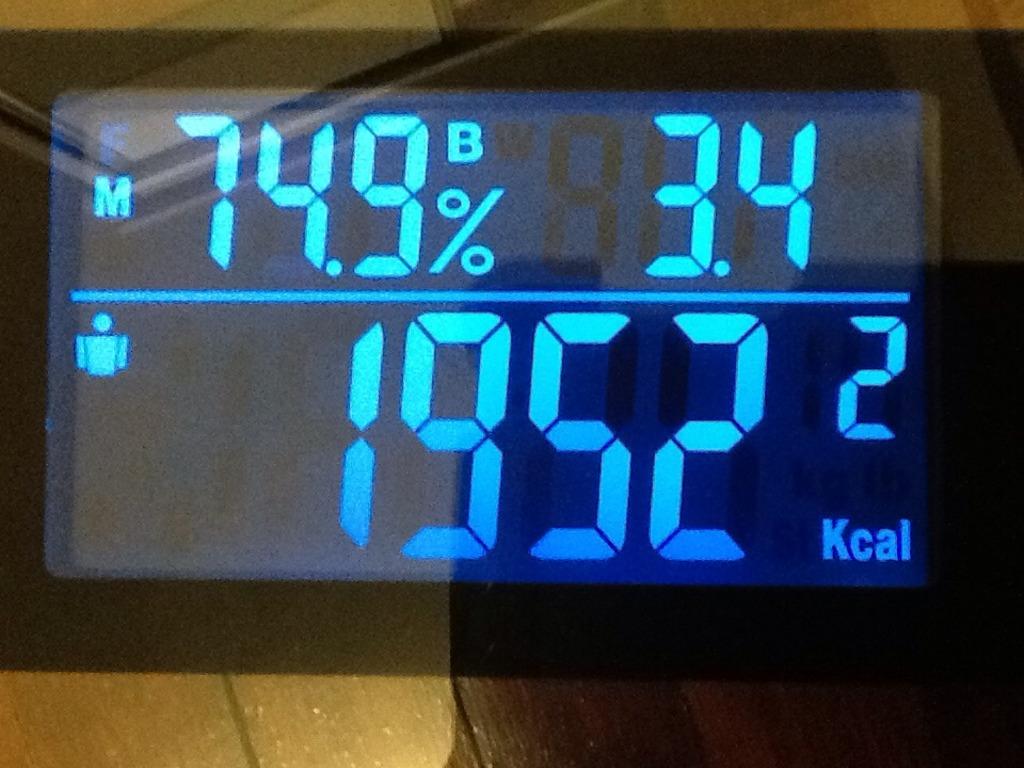What is the percent?
Your answer should be compact. 74.9%. 